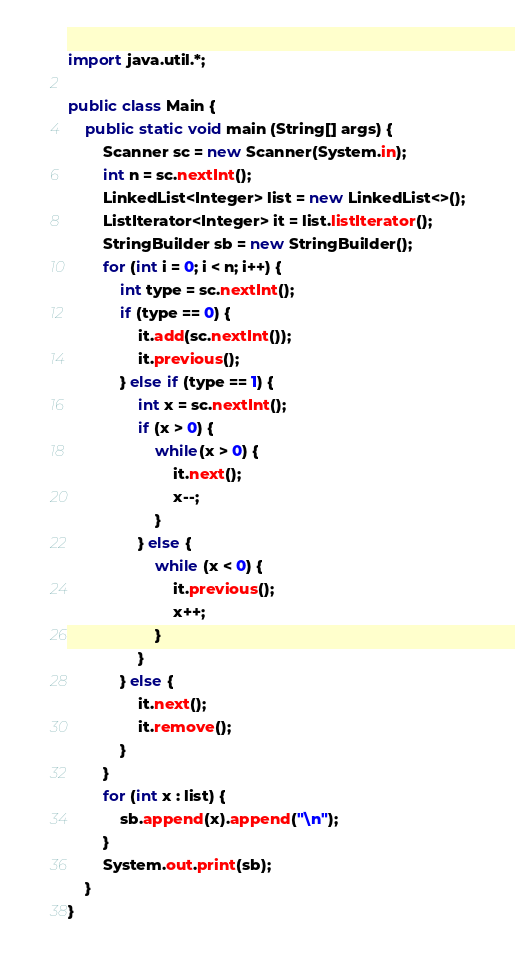Convert code to text. <code><loc_0><loc_0><loc_500><loc_500><_Java_>import java.util.*;

public class Main {
	public static void main (String[] args) {
		Scanner sc = new Scanner(System.in);
		int n = sc.nextInt();
		LinkedList<Integer> list = new LinkedList<>();
		ListIterator<Integer> it = list.listIterator();
		StringBuilder sb = new StringBuilder();
		for (int i = 0; i < n; i++) {
		    int type = sc.nextInt();
		    if (type == 0) {
		        it.add(sc.nextInt());
		        it.previous();
		    } else if (type == 1) {
		        int x = sc.nextInt();
		        if (x > 0) {
		            while(x > 0) {
		                it.next();
		                x--;
		            }
		        } else {
		            while (x < 0) {
		                it.previous();
		                x++;
		            }
		        }
		    } else {
		        it.next();
		        it.remove();
		    }
		}
		for (int x : list) {
		    sb.append(x).append("\n");
		}
		System.out.print(sb);
	}
}

</code> 